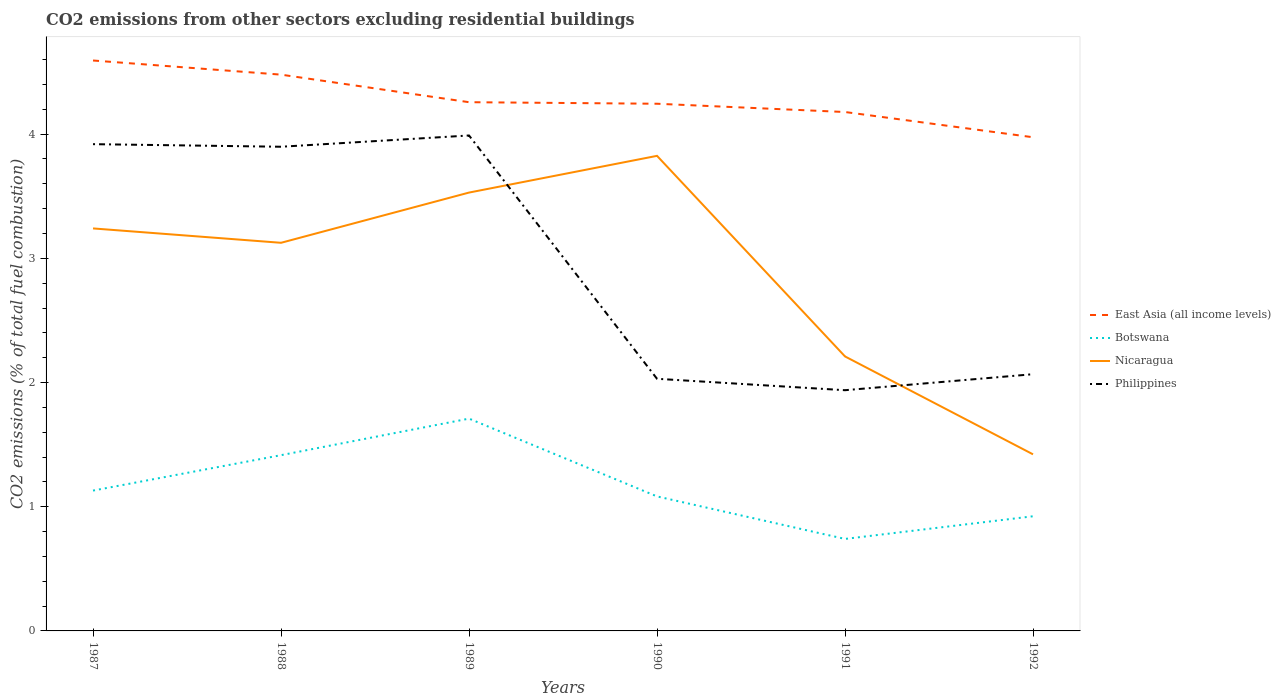How many different coloured lines are there?
Provide a short and direct response. 4. Does the line corresponding to Nicaragua intersect with the line corresponding to East Asia (all income levels)?
Offer a terse response. No. Across all years, what is the maximum total CO2 emitted in Nicaragua?
Make the answer very short. 1.42. What is the total total CO2 emitted in Philippines in the graph?
Keep it short and to the point. 1.89. What is the difference between the highest and the second highest total CO2 emitted in Philippines?
Offer a very short reply. 2.05. What is the difference between the highest and the lowest total CO2 emitted in East Asia (all income levels)?
Offer a very short reply. 2. Is the total CO2 emitted in Botswana strictly greater than the total CO2 emitted in Philippines over the years?
Provide a succinct answer. Yes. What is the difference between two consecutive major ticks on the Y-axis?
Provide a succinct answer. 1. Does the graph contain any zero values?
Offer a very short reply. No. Where does the legend appear in the graph?
Offer a terse response. Center right. What is the title of the graph?
Give a very brief answer. CO2 emissions from other sectors excluding residential buildings. What is the label or title of the Y-axis?
Offer a very short reply. CO2 emissions (% of total fuel combustion). What is the CO2 emissions (% of total fuel combustion) in East Asia (all income levels) in 1987?
Your answer should be very brief. 4.59. What is the CO2 emissions (% of total fuel combustion) in Botswana in 1987?
Offer a very short reply. 1.13. What is the CO2 emissions (% of total fuel combustion) in Nicaragua in 1987?
Give a very brief answer. 3.24. What is the CO2 emissions (% of total fuel combustion) of Philippines in 1987?
Keep it short and to the point. 3.92. What is the CO2 emissions (% of total fuel combustion) in East Asia (all income levels) in 1988?
Provide a short and direct response. 4.48. What is the CO2 emissions (% of total fuel combustion) of Botswana in 1988?
Offer a very short reply. 1.42. What is the CO2 emissions (% of total fuel combustion) in Nicaragua in 1988?
Your answer should be very brief. 3.12. What is the CO2 emissions (% of total fuel combustion) of Philippines in 1988?
Your answer should be compact. 3.9. What is the CO2 emissions (% of total fuel combustion) in East Asia (all income levels) in 1989?
Provide a succinct answer. 4.26. What is the CO2 emissions (% of total fuel combustion) of Botswana in 1989?
Make the answer very short. 1.71. What is the CO2 emissions (% of total fuel combustion) in Nicaragua in 1989?
Offer a terse response. 3.53. What is the CO2 emissions (% of total fuel combustion) of Philippines in 1989?
Ensure brevity in your answer.  3.99. What is the CO2 emissions (% of total fuel combustion) of East Asia (all income levels) in 1990?
Offer a very short reply. 4.24. What is the CO2 emissions (% of total fuel combustion) of Botswana in 1990?
Your answer should be very brief. 1.08. What is the CO2 emissions (% of total fuel combustion) in Nicaragua in 1990?
Keep it short and to the point. 3.83. What is the CO2 emissions (% of total fuel combustion) of Philippines in 1990?
Your response must be concise. 2.03. What is the CO2 emissions (% of total fuel combustion) of East Asia (all income levels) in 1991?
Offer a very short reply. 4.18. What is the CO2 emissions (% of total fuel combustion) in Botswana in 1991?
Your response must be concise. 0.74. What is the CO2 emissions (% of total fuel combustion) of Nicaragua in 1991?
Offer a terse response. 2.21. What is the CO2 emissions (% of total fuel combustion) of Philippines in 1991?
Give a very brief answer. 1.94. What is the CO2 emissions (% of total fuel combustion) of East Asia (all income levels) in 1992?
Make the answer very short. 3.97. What is the CO2 emissions (% of total fuel combustion) in Botswana in 1992?
Your response must be concise. 0.92. What is the CO2 emissions (% of total fuel combustion) of Nicaragua in 1992?
Your answer should be compact. 1.42. What is the CO2 emissions (% of total fuel combustion) in Philippines in 1992?
Provide a succinct answer. 2.07. Across all years, what is the maximum CO2 emissions (% of total fuel combustion) of East Asia (all income levels)?
Your response must be concise. 4.59. Across all years, what is the maximum CO2 emissions (% of total fuel combustion) of Botswana?
Keep it short and to the point. 1.71. Across all years, what is the maximum CO2 emissions (% of total fuel combustion) in Nicaragua?
Provide a succinct answer. 3.83. Across all years, what is the maximum CO2 emissions (% of total fuel combustion) of Philippines?
Give a very brief answer. 3.99. Across all years, what is the minimum CO2 emissions (% of total fuel combustion) in East Asia (all income levels)?
Ensure brevity in your answer.  3.97. Across all years, what is the minimum CO2 emissions (% of total fuel combustion) in Botswana?
Offer a terse response. 0.74. Across all years, what is the minimum CO2 emissions (% of total fuel combustion) in Nicaragua?
Provide a short and direct response. 1.42. Across all years, what is the minimum CO2 emissions (% of total fuel combustion) of Philippines?
Provide a short and direct response. 1.94. What is the total CO2 emissions (% of total fuel combustion) in East Asia (all income levels) in the graph?
Offer a terse response. 25.73. What is the total CO2 emissions (% of total fuel combustion) of Botswana in the graph?
Give a very brief answer. 7. What is the total CO2 emissions (% of total fuel combustion) in Nicaragua in the graph?
Your response must be concise. 17.35. What is the total CO2 emissions (% of total fuel combustion) of Philippines in the graph?
Provide a succinct answer. 17.84. What is the difference between the CO2 emissions (% of total fuel combustion) of East Asia (all income levels) in 1987 and that in 1988?
Offer a terse response. 0.11. What is the difference between the CO2 emissions (% of total fuel combustion) of Botswana in 1987 and that in 1988?
Your answer should be compact. -0.29. What is the difference between the CO2 emissions (% of total fuel combustion) in Nicaragua in 1987 and that in 1988?
Keep it short and to the point. 0.12. What is the difference between the CO2 emissions (% of total fuel combustion) in Philippines in 1987 and that in 1988?
Give a very brief answer. 0.02. What is the difference between the CO2 emissions (% of total fuel combustion) in East Asia (all income levels) in 1987 and that in 1989?
Provide a succinct answer. 0.34. What is the difference between the CO2 emissions (% of total fuel combustion) of Botswana in 1987 and that in 1989?
Keep it short and to the point. -0.58. What is the difference between the CO2 emissions (% of total fuel combustion) in Nicaragua in 1987 and that in 1989?
Provide a short and direct response. -0.29. What is the difference between the CO2 emissions (% of total fuel combustion) in Philippines in 1987 and that in 1989?
Offer a very short reply. -0.07. What is the difference between the CO2 emissions (% of total fuel combustion) of East Asia (all income levels) in 1987 and that in 1990?
Make the answer very short. 0.35. What is the difference between the CO2 emissions (% of total fuel combustion) of Botswana in 1987 and that in 1990?
Give a very brief answer. 0.05. What is the difference between the CO2 emissions (% of total fuel combustion) of Nicaragua in 1987 and that in 1990?
Provide a succinct answer. -0.58. What is the difference between the CO2 emissions (% of total fuel combustion) of Philippines in 1987 and that in 1990?
Provide a succinct answer. 1.89. What is the difference between the CO2 emissions (% of total fuel combustion) of East Asia (all income levels) in 1987 and that in 1991?
Ensure brevity in your answer.  0.41. What is the difference between the CO2 emissions (% of total fuel combustion) in Botswana in 1987 and that in 1991?
Offer a very short reply. 0.39. What is the difference between the CO2 emissions (% of total fuel combustion) in Nicaragua in 1987 and that in 1991?
Offer a terse response. 1.03. What is the difference between the CO2 emissions (% of total fuel combustion) of Philippines in 1987 and that in 1991?
Keep it short and to the point. 1.98. What is the difference between the CO2 emissions (% of total fuel combustion) in East Asia (all income levels) in 1987 and that in 1992?
Ensure brevity in your answer.  0.62. What is the difference between the CO2 emissions (% of total fuel combustion) in Botswana in 1987 and that in 1992?
Your answer should be very brief. 0.21. What is the difference between the CO2 emissions (% of total fuel combustion) of Nicaragua in 1987 and that in 1992?
Offer a very short reply. 1.82. What is the difference between the CO2 emissions (% of total fuel combustion) in Philippines in 1987 and that in 1992?
Your answer should be very brief. 1.85. What is the difference between the CO2 emissions (% of total fuel combustion) in East Asia (all income levels) in 1988 and that in 1989?
Your answer should be very brief. 0.22. What is the difference between the CO2 emissions (% of total fuel combustion) of Botswana in 1988 and that in 1989?
Ensure brevity in your answer.  -0.29. What is the difference between the CO2 emissions (% of total fuel combustion) of Nicaragua in 1988 and that in 1989?
Make the answer very short. -0.4. What is the difference between the CO2 emissions (% of total fuel combustion) of Philippines in 1988 and that in 1989?
Provide a short and direct response. -0.09. What is the difference between the CO2 emissions (% of total fuel combustion) of East Asia (all income levels) in 1988 and that in 1990?
Ensure brevity in your answer.  0.23. What is the difference between the CO2 emissions (% of total fuel combustion) in Botswana in 1988 and that in 1990?
Give a very brief answer. 0.33. What is the difference between the CO2 emissions (% of total fuel combustion) in Nicaragua in 1988 and that in 1990?
Your answer should be compact. -0.7. What is the difference between the CO2 emissions (% of total fuel combustion) of Philippines in 1988 and that in 1990?
Your response must be concise. 1.87. What is the difference between the CO2 emissions (% of total fuel combustion) in East Asia (all income levels) in 1988 and that in 1991?
Offer a terse response. 0.3. What is the difference between the CO2 emissions (% of total fuel combustion) in Botswana in 1988 and that in 1991?
Keep it short and to the point. 0.67. What is the difference between the CO2 emissions (% of total fuel combustion) in Nicaragua in 1988 and that in 1991?
Offer a terse response. 0.92. What is the difference between the CO2 emissions (% of total fuel combustion) of Philippines in 1988 and that in 1991?
Your answer should be very brief. 1.96. What is the difference between the CO2 emissions (% of total fuel combustion) in East Asia (all income levels) in 1988 and that in 1992?
Provide a short and direct response. 0.5. What is the difference between the CO2 emissions (% of total fuel combustion) in Botswana in 1988 and that in 1992?
Offer a terse response. 0.49. What is the difference between the CO2 emissions (% of total fuel combustion) of Nicaragua in 1988 and that in 1992?
Make the answer very short. 1.7. What is the difference between the CO2 emissions (% of total fuel combustion) in Philippines in 1988 and that in 1992?
Your response must be concise. 1.83. What is the difference between the CO2 emissions (% of total fuel combustion) of East Asia (all income levels) in 1989 and that in 1990?
Provide a succinct answer. 0.01. What is the difference between the CO2 emissions (% of total fuel combustion) in Botswana in 1989 and that in 1990?
Offer a terse response. 0.63. What is the difference between the CO2 emissions (% of total fuel combustion) in Nicaragua in 1989 and that in 1990?
Your response must be concise. -0.3. What is the difference between the CO2 emissions (% of total fuel combustion) in Philippines in 1989 and that in 1990?
Ensure brevity in your answer.  1.96. What is the difference between the CO2 emissions (% of total fuel combustion) in East Asia (all income levels) in 1989 and that in 1991?
Offer a very short reply. 0.08. What is the difference between the CO2 emissions (% of total fuel combustion) in Botswana in 1989 and that in 1991?
Keep it short and to the point. 0.97. What is the difference between the CO2 emissions (% of total fuel combustion) in Nicaragua in 1989 and that in 1991?
Offer a terse response. 1.32. What is the difference between the CO2 emissions (% of total fuel combustion) of Philippines in 1989 and that in 1991?
Your response must be concise. 2.05. What is the difference between the CO2 emissions (% of total fuel combustion) in East Asia (all income levels) in 1989 and that in 1992?
Provide a succinct answer. 0.28. What is the difference between the CO2 emissions (% of total fuel combustion) of Botswana in 1989 and that in 1992?
Provide a succinct answer. 0.79. What is the difference between the CO2 emissions (% of total fuel combustion) in Nicaragua in 1989 and that in 1992?
Keep it short and to the point. 2.11. What is the difference between the CO2 emissions (% of total fuel combustion) of Philippines in 1989 and that in 1992?
Keep it short and to the point. 1.92. What is the difference between the CO2 emissions (% of total fuel combustion) in East Asia (all income levels) in 1990 and that in 1991?
Your answer should be very brief. 0.07. What is the difference between the CO2 emissions (% of total fuel combustion) in Botswana in 1990 and that in 1991?
Provide a short and direct response. 0.34. What is the difference between the CO2 emissions (% of total fuel combustion) of Nicaragua in 1990 and that in 1991?
Your answer should be very brief. 1.62. What is the difference between the CO2 emissions (% of total fuel combustion) in Philippines in 1990 and that in 1991?
Ensure brevity in your answer.  0.09. What is the difference between the CO2 emissions (% of total fuel combustion) in East Asia (all income levels) in 1990 and that in 1992?
Give a very brief answer. 0.27. What is the difference between the CO2 emissions (% of total fuel combustion) in Botswana in 1990 and that in 1992?
Your answer should be very brief. 0.16. What is the difference between the CO2 emissions (% of total fuel combustion) of Nicaragua in 1990 and that in 1992?
Offer a very short reply. 2.4. What is the difference between the CO2 emissions (% of total fuel combustion) in Philippines in 1990 and that in 1992?
Your response must be concise. -0.04. What is the difference between the CO2 emissions (% of total fuel combustion) in East Asia (all income levels) in 1991 and that in 1992?
Provide a short and direct response. 0.2. What is the difference between the CO2 emissions (% of total fuel combustion) in Botswana in 1991 and that in 1992?
Provide a succinct answer. -0.18. What is the difference between the CO2 emissions (% of total fuel combustion) in Nicaragua in 1991 and that in 1992?
Your answer should be compact. 0.79. What is the difference between the CO2 emissions (% of total fuel combustion) of Philippines in 1991 and that in 1992?
Your response must be concise. -0.13. What is the difference between the CO2 emissions (% of total fuel combustion) in East Asia (all income levels) in 1987 and the CO2 emissions (% of total fuel combustion) in Botswana in 1988?
Your answer should be compact. 3.18. What is the difference between the CO2 emissions (% of total fuel combustion) of East Asia (all income levels) in 1987 and the CO2 emissions (% of total fuel combustion) of Nicaragua in 1988?
Ensure brevity in your answer.  1.47. What is the difference between the CO2 emissions (% of total fuel combustion) of East Asia (all income levels) in 1987 and the CO2 emissions (% of total fuel combustion) of Philippines in 1988?
Provide a succinct answer. 0.69. What is the difference between the CO2 emissions (% of total fuel combustion) in Botswana in 1987 and the CO2 emissions (% of total fuel combustion) in Nicaragua in 1988?
Ensure brevity in your answer.  -2. What is the difference between the CO2 emissions (% of total fuel combustion) of Botswana in 1987 and the CO2 emissions (% of total fuel combustion) of Philippines in 1988?
Your answer should be compact. -2.77. What is the difference between the CO2 emissions (% of total fuel combustion) of Nicaragua in 1987 and the CO2 emissions (% of total fuel combustion) of Philippines in 1988?
Your answer should be very brief. -0.66. What is the difference between the CO2 emissions (% of total fuel combustion) in East Asia (all income levels) in 1987 and the CO2 emissions (% of total fuel combustion) in Botswana in 1989?
Give a very brief answer. 2.88. What is the difference between the CO2 emissions (% of total fuel combustion) of East Asia (all income levels) in 1987 and the CO2 emissions (% of total fuel combustion) of Nicaragua in 1989?
Offer a terse response. 1.06. What is the difference between the CO2 emissions (% of total fuel combustion) of East Asia (all income levels) in 1987 and the CO2 emissions (% of total fuel combustion) of Philippines in 1989?
Your response must be concise. 0.6. What is the difference between the CO2 emissions (% of total fuel combustion) of Botswana in 1987 and the CO2 emissions (% of total fuel combustion) of Nicaragua in 1989?
Ensure brevity in your answer.  -2.4. What is the difference between the CO2 emissions (% of total fuel combustion) of Botswana in 1987 and the CO2 emissions (% of total fuel combustion) of Philippines in 1989?
Your answer should be compact. -2.86. What is the difference between the CO2 emissions (% of total fuel combustion) in Nicaragua in 1987 and the CO2 emissions (% of total fuel combustion) in Philippines in 1989?
Provide a succinct answer. -0.75. What is the difference between the CO2 emissions (% of total fuel combustion) in East Asia (all income levels) in 1987 and the CO2 emissions (% of total fuel combustion) in Botswana in 1990?
Provide a short and direct response. 3.51. What is the difference between the CO2 emissions (% of total fuel combustion) of East Asia (all income levels) in 1987 and the CO2 emissions (% of total fuel combustion) of Nicaragua in 1990?
Offer a terse response. 0.77. What is the difference between the CO2 emissions (% of total fuel combustion) of East Asia (all income levels) in 1987 and the CO2 emissions (% of total fuel combustion) of Philippines in 1990?
Provide a short and direct response. 2.56. What is the difference between the CO2 emissions (% of total fuel combustion) in Botswana in 1987 and the CO2 emissions (% of total fuel combustion) in Nicaragua in 1990?
Your response must be concise. -2.7. What is the difference between the CO2 emissions (% of total fuel combustion) of Botswana in 1987 and the CO2 emissions (% of total fuel combustion) of Philippines in 1990?
Your answer should be compact. -0.9. What is the difference between the CO2 emissions (% of total fuel combustion) of Nicaragua in 1987 and the CO2 emissions (% of total fuel combustion) of Philippines in 1990?
Your answer should be very brief. 1.21. What is the difference between the CO2 emissions (% of total fuel combustion) of East Asia (all income levels) in 1987 and the CO2 emissions (% of total fuel combustion) of Botswana in 1991?
Offer a very short reply. 3.85. What is the difference between the CO2 emissions (% of total fuel combustion) of East Asia (all income levels) in 1987 and the CO2 emissions (% of total fuel combustion) of Nicaragua in 1991?
Provide a short and direct response. 2.38. What is the difference between the CO2 emissions (% of total fuel combustion) in East Asia (all income levels) in 1987 and the CO2 emissions (% of total fuel combustion) in Philippines in 1991?
Provide a short and direct response. 2.65. What is the difference between the CO2 emissions (% of total fuel combustion) in Botswana in 1987 and the CO2 emissions (% of total fuel combustion) in Nicaragua in 1991?
Provide a succinct answer. -1.08. What is the difference between the CO2 emissions (% of total fuel combustion) of Botswana in 1987 and the CO2 emissions (% of total fuel combustion) of Philippines in 1991?
Give a very brief answer. -0.81. What is the difference between the CO2 emissions (% of total fuel combustion) in Nicaragua in 1987 and the CO2 emissions (% of total fuel combustion) in Philippines in 1991?
Your answer should be very brief. 1.3. What is the difference between the CO2 emissions (% of total fuel combustion) of East Asia (all income levels) in 1987 and the CO2 emissions (% of total fuel combustion) of Botswana in 1992?
Provide a short and direct response. 3.67. What is the difference between the CO2 emissions (% of total fuel combustion) of East Asia (all income levels) in 1987 and the CO2 emissions (% of total fuel combustion) of Nicaragua in 1992?
Provide a succinct answer. 3.17. What is the difference between the CO2 emissions (% of total fuel combustion) in East Asia (all income levels) in 1987 and the CO2 emissions (% of total fuel combustion) in Philippines in 1992?
Offer a very short reply. 2.53. What is the difference between the CO2 emissions (% of total fuel combustion) of Botswana in 1987 and the CO2 emissions (% of total fuel combustion) of Nicaragua in 1992?
Ensure brevity in your answer.  -0.29. What is the difference between the CO2 emissions (% of total fuel combustion) in Botswana in 1987 and the CO2 emissions (% of total fuel combustion) in Philippines in 1992?
Provide a short and direct response. -0.94. What is the difference between the CO2 emissions (% of total fuel combustion) in Nicaragua in 1987 and the CO2 emissions (% of total fuel combustion) in Philippines in 1992?
Ensure brevity in your answer.  1.17. What is the difference between the CO2 emissions (% of total fuel combustion) in East Asia (all income levels) in 1988 and the CO2 emissions (% of total fuel combustion) in Botswana in 1989?
Keep it short and to the point. 2.77. What is the difference between the CO2 emissions (% of total fuel combustion) in East Asia (all income levels) in 1988 and the CO2 emissions (% of total fuel combustion) in Nicaragua in 1989?
Make the answer very short. 0.95. What is the difference between the CO2 emissions (% of total fuel combustion) of East Asia (all income levels) in 1988 and the CO2 emissions (% of total fuel combustion) of Philippines in 1989?
Keep it short and to the point. 0.49. What is the difference between the CO2 emissions (% of total fuel combustion) of Botswana in 1988 and the CO2 emissions (% of total fuel combustion) of Nicaragua in 1989?
Give a very brief answer. -2.11. What is the difference between the CO2 emissions (% of total fuel combustion) of Botswana in 1988 and the CO2 emissions (% of total fuel combustion) of Philippines in 1989?
Provide a succinct answer. -2.57. What is the difference between the CO2 emissions (% of total fuel combustion) in Nicaragua in 1988 and the CO2 emissions (% of total fuel combustion) in Philippines in 1989?
Make the answer very short. -0.86. What is the difference between the CO2 emissions (% of total fuel combustion) in East Asia (all income levels) in 1988 and the CO2 emissions (% of total fuel combustion) in Botswana in 1990?
Make the answer very short. 3.4. What is the difference between the CO2 emissions (% of total fuel combustion) of East Asia (all income levels) in 1988 and the CO2 emissions (% of total fuel combustion) of Nicaragua in 1990?
Keep it short and to the point. 0.65. What is the difference between the CO2 emissions (% of total fuel combustion) of East Asia (all income levels) in 1988 and the CO2 emissions (% of total fuel combustion) of Philippines in 1990?
Your response must be concise. 2.45. What is the difference between the CO2 emissions (% of total fuel combustion) of Botswana in 1988 and the CO2 emissions (% of total fuel combustion) of Nicaragua in 1990?
Provide a short and direct response. -2.41. What is the difference between the CO2 emissions (% of total fuel combustion) of Botswana in 1988 and the CO2 emissions (% of total fuel combustion) of Philippines in 1990?
Make the answer very short. -0.61. What is the difference between the CO2 emissions (% of total fuel combustion) of Nicaragua in 1988 and the CO2 emissions (% of total fuel combustion) of Philippines in 1990?
Offer a terse response. 1.09. What is the difference between the CO2 emissions (% of total fuel combustion) of East Asia (all income levels) in 1988 and the CO2 emissions (% of total fuel combustion) of Botswana in 1991?
Provide a short and direct response. 3.74. What is the difference between the CO2 emissions (% of total fuel combustion) in East Asia (all income levels) in 1988 and the CO2 emissions (% of total fuel combustion) in Nicaragua in 1991?
Give a very brief answer. 2.27. What is the difference between the CO2 emissions (% of total fuel combustion) of East Asia (all income levels) in 1988 and the CO2 emissions (% of total fuel combustion) of Philippines in 1991?
Provide a short and direct response. 2.54. What is the difference between the CO2 emissions (% of total fuel combustion) of Botswana in 1988 and the CO2 emissions (% of total fuel combustion) of Nicaragua in 1991?
Offer a very short reply. -0.79. What is the difference between the CO2 emissions (% of total fuel combustion) of Botswana in 1988 and the CO2 emissions (% of total fuel combustion) of Philippines in 1991?
Your answer should be very brief. -0.52. What is the difference between the CO2 emissions (% of total fuel combustion) in Nicaragua in 1988 and the CO2 emissions (% of total fuel combustion) in Philippines in 1991?
Offer a very short reply. 1.19. What is the difference between the CO2 emissions (% of total fuel combustion) in East Asia (all income levels) in 1988 and the CO2 emissions (% of total fuel combustion) in Botswana in 1992?
Offer a terse response. 3.56. What is the difference between the CO2 emissions (% of total fuel combustion) in East Asia (all income levels) in 1988 and the CO2 emissions (% of total fuel combustion) in Nicaragua in 1992?
Keep it short and to the point. 3.06. What is the difference between the CO2 emissions (% of total fuel combustion) in East Asia (all income levels) in 1988 and the CO2 emissions (% of total fuel combustion) in Philippines in 1992?
Your response must be concise. 2.41. What is the difference between the CO2 emissions (% of total fuel combustion) of Botswana in 1988 and the CO2 emissions (% of total fuel combustion) of Nicaragua in 1992?
Make the answer very short. -0.01. What is the difference between the CO2 emissions (% of total fuel combustion) of Botswana in 1988 and the CO2 emissions (% of total fuel combustion) of Philippines in 1992?
Offer a terse response. -0.65. What is the difference between the CO2 emissions (% of total fuel combustion) of Nicaragua in 1988 and the CO2 emissions (% of total fuel combustion) of Philippines in 1992?
Your answer should be compact. 1.06. What is the difference between the CO2 emissions (% of total fuel combustion) of East Asia (all income levels) in 1989 and the CO2 emissions (% of total fuel combustion) of Botswana in 1990?
Offer a terse response. 3.17. What is the difference between the CO2 emissions (% of total fuel combustion) of East Asia (all income levels) in 1989 and the CO2 emissions (% of total fuel combustion) of Nicaragua in 1990?
Provide a short and direct response. 0.43. What is the difference between the CO2 emissions (% of total fuel combustion) in East Asia (all income levels) in 1989 and the CO2 emissions (% of total fuel combustion) in Philippines in 1990?
Ensure brevity in your answer.  2.23. What is the difference between the CO2 emissions (% of total fuel combustion) of Botswana in 1989 and the CO2 emissions (% of total fuel combustion) of Nicaragua in 1990?
Your answer should be very brief. -2.12. What is the difference between the CO2 emissions (% of total fuel combustion) in Botswana in 1989 and the CO2 emissions (% of total fuel combustion) in Philippines in 1990?
Provide a short and direct response. -0.32. What is the difference between the CO2 emissions (% of total fuel combustion) in Nicaragua in 1989 and the CO2 emissions (% of total fuel combustion) in Philippines in 1990?
Make the answer very short. 1.5. What is the difference between the CO2 emissions (% of total fuel combustion) in East Asia (all income levels) in 1989 and the CO2 emissions (% of total fuel combustion) in Botswana in 1991?
Keep it short and to the point. 3.52. What is the difference between the CO2 emissions (% of total fuel combustion) of East Asia (all income levels) in 1989 and the CO2 emissions (% of total fuel combustion) of Nicaragua in 1991?
Provide a succinct answer. 2.05. What is the difference between the CO2 emissions (% of total fuel combustion) in East Asia (all income levels) in 1989 and the CO2 emissions (% of total fuel combustion) in Philippines in 1991?
Keep it short and to the point. 2.32. What is the difference between the CO2 emissions (% of total fuel combustion) of Botswana in 1989 and the CO2 emissions (% of total fuel combustion) of Nicaragua in 1991?
Your response must be concise. -0.5. What is the difference between the CO2 emissions (% of total fuel combustion) in Botswana in 1989 and the CO2 emissions (% of total fuel combustion) in Philippines in 1991?
Your answer should be compact. -0.23. What is the difference between the CO2 emissions (% of total fuel combustion) in Nicaragua in 1989 and the CO2 emissions (% of total fuel combustion) in Philippines in 1991?
Offer a very short reply. 1.59. What is the difference between the CO2 emissions (% of total fuel combustion) of East Asia (all income levels) in 1989 and the CO2 emissions (% of total fuel combustion) of Botswana in 1992?
Provide a short and direct response. 3.33. What is the difference between the CO2 emissions (% of total fuel combustion) of East Asia (all income levels) in 1989 and the CO2 emissions (% of total fuel combustion) of Nicaragua in 1992?
Make the answer very short. 2.84. What is the difference between the CO2 emissions (% of total fuel combustion) in East Asia (all income levels) in 1989 and the CO2 emissions (% of total fuel combustion) in Philippines in 1992?
Your response must be concise. 2.19. What is the difference between the CO2 emissions (% of total fuel combustion) in Botswana in 1989 and the CO2 emissions (% of total fuel combustion) in Nicaragua in 1992?
Ensure brevity in your answer.  0.29. What is the difference between the CO2 emissions (% of total fuel combustion) in Botswana in 1989 and the CO2 emissions (% of total fuel combustion) in Philippines in 1992?
Keep it short and to the point. -0.36. What is the difference between the CO2 emissions (% of total fuel combustion) in Nicaragua in 1989 and the CO2 emissions (% of total fuel combustion) in Philippines in 1992?
Offer a very short reply. 1.46. What is the difference between the CO2 emissions (% of total fuel combustion) in East Asia (all income levels) in 1990 and the CO2 emissions (% of total fuel combustion) in Botswana in 1991?
Offer a terse response. 3.5. What is the difference between the CO2 emissions (% of total fuel combustion) of East Asia (all income levels) in 1990 and the CO2 emissions (% of total fuel combustion) of Nicaragua in 1991?
Provide a succinct answer. 2.03. What is the difference between the CO2 emissions (% of total fuel combustion) of East Asia (all income levels) in 1990 and the CO2 emissions (% of total fuel combustion) of Philippines in 1991?
Your answer should be compact. 2.31. What is the difference between the CO2 emissions (% of total fuel combustion) in Botswana in 1990 and the CO2 emissions (% of total fuel combustion) in Nicaragua in 1991?
Keep it short and to the point. -1.13. What is the difference between the CO2 emissions (% of total fuel combustion) in Botswana in 1990 and the CO2 emissions (% of total fuel combustion) in Philippines in 1991?
Your response must be concise. -0.86. What is the difference between the CO2 emissions (% of total fuel combustion) in Nicaragua in 1990 and the CO2 emissions (% of total fuel combustion) in Philippines in 1991?
Make the answer very short. 1.89. What is the difference between the CO2 emissions (% of total fuel combustion) in East Asia (all income levels) in 1990 and the CO2 emissions (% of total fuel combustion) in Botswana in 1992?
Make the answer very short. 3.32. What is the difference between the CO2 emissions (% of total fuel combustion) of East Asia (all income levels) in 1990 and the CO2 emissions (% of total fuel combustion) of Nicaragua in 1992?
Your response must be concise. 2.82. What is the difference between the CO2 emissions (% of total fuel combustion) of East Asia (all income levels) in 1990 and the CO2 emissions (% of total fuel combustion) of Philippines in 1992?
Ensure brevity in your answer.  2.18. What is the difference between the CO2 emissions (% of total fuel combustion) in Botswana in 1990 and the CO2 emissions (% of total fuel combustion) in Nicaragua in 1992?
Ensure brevity in your answer.  -0.34. What is the difference between the CO2 emissions (% of total fuel combustion) of Botswana in 1990 and the CO2 emissions (% of total fuel combustion) of Philippines in 1992?
Your response must be concise. -0.98. What is the difference between the CO2 emissions (% of total fuel combustion) in Nicaragua in 1990 and the CO2 emissions (% of total fuel combustion) in Philippines in 1992?
Your response must be concise. 1.76. What is the difference between the CO2 emissions (% of total fuel combustion) of East Asia (all income levels) in 1991 and the CO2 emissions (% of total fuel combustion) of Botswana in 1992?
Give a very brief answer. 3.25. What is the difference between the CO2 emissions (% of total fuel combustion) of East Asia (all income levels) in 1991 and the CO2 emissions (% of total fuel combustion) of Nicaragua in 1992?
Your response must be concise. 2.76. What is the difference between the CO2 emissions (% of total fuel combustion) in East Asia (all income levels) in 1991 and the CO2 emissions (% of total fuel combustion) in Philippines in 1992?
Keep it short and to the point. 2.11. What is the difference between the CO2 emissions (% of total fuel combustion) in Botswana in 1991 and the CO2 emissions (% of total fuel combustion) in Nicaragua in 1992?
Your response must be concise. -0.68. What is the difference between the CO2 emissions (% of total fuel combustion) in Botswana in 1991 and the CO2 emissions (% of total fuel combustion) in Philippines in 1992?
Your response must be concise. -1.33. What is the difference between the CO2 emissions (% of total fuel combustion) of Nicaragua in 1991 and the CO2 emissions (% of total fuel combustion) of Philippines in 1992?
Provide a short and direct response. 0.14. What is the average CO2 emissions (% of total fuel combustion) of East Asia (all income levels) per year?
Your response must be concise. 4.29. What is the average CO2 emissions (% of total fuel combustion) in Botswana per year?
Give a very brief answer. 1.17. What is the average CO2 emissions (% of total fuel combustion) of Nicaragua per year?
Offer a very short reply. 2.89. What is the average CO2 emissions (% of total fuel combustion) of Philippines per year?
Ensure brevity in your answer.  2.97. In the year 1987, what is the difference between the CO2 emissions (% of total fuel combustion) of East Asia (all income levels) and CO2 emissions (% of total fuel combustion) of Botswana?
Offer a very short reply. 3.46. In the year 1987, what is the difference between the CO2 emissions (% of total fuel combustion) of East Asia (all income levels) and CO2 emissions (% of total fuel combustion) of Nicaragua?
Offer a very short reply. 1.35. In the year 1987, what is the difference between the CO2 emissions (% of total fuel combustion) of East Asia (all income levels) and CO2 emissions (% of total fuel combustion) of Philippines?
Keep it short and to the point. 0.67. In the year 1987, what is the difference between the CO2 emissions (% of total fuel combustion) of Botswana and CO2 emissions (% of total fuel combustion) of Nicaragua?
Offer a terse response. -2.11. In the year 1987, what is the difference between the CO2 emissions (% of total fuel combustion) of Botswana and CO2 emissions (% of total fuel combustion) of Philippines?
Provide a succinct answer. -2.79. In the year 1987, what is the difference between the CO2 emissions (% of total fuel combustion) in Nicaragua and CO2 emissions (% of total fuel combustion) in Philippines?
Your response must be concise. -0.68. In the year 1988, what is the difference between the CO2 emissions (% of total fuel combustion) in East Asia (all income levels) and CO2 emissions (% of total fuel combustion) in Botswana?
Give a very brief answer. 3.06. In the year 1988, what is the difference between the CO2 emissions (% of total fuel combustion) in East Asia (all income levels) and CO2 emissions (% of total fuel combustion) in Nicaragua?
Offer a very short reply. 1.35. In the year 1988, what is the difference between the CO2 emissions (% of total fuel combustion) of East Asia (all income levels) and CO2 emissions (% of total fuel combustion) of Philippines?
Offer a very short reply. 0.58. In the year 1988, what is the difference between the CO2 emissions (% of total fuel combustion) in Botswana and CO2 emissions (% of total fuel combustion) in Nicaragua?
Provide a succinct answer. -1.71. In the year 1988, what is the difference between the CO2 emissions (% of total fuel combustion) in Botswana and CO2 emissions (% of total fuel combustion) in Philippines?
Provide a succinct answer. -2.48. In the year 1988, what is the difference between the CO2 emissions (% of total fuel combustion) in Nicaragua and CO2 emissions (% of total fuel combustion) in Philippines?
Your answer should be compact. -0.77. In the year 1989, what is the difference between the CO2 emissions (% of total fuel combustion) of East Asia (all income levels) and CO2 emissions (% of total fuel combustion) of Botswana?
Your answer should be compact. 2.55. In the year 1989, what is the difference between the CO2 emissions (% of total fuel combustion) in East Asia (all income levels) and CO2 emissions (% of total fuel combustion) in Nicaragua?
Ensure brevity in your answer.  0.73. In the year 1989, what is the difference between the CO2 emissions (% of total fuel combustion) in East Asia (all income levels) and CO2 emissions (% of total fuel combustion) in Philippines?
Make the answer very short. 0.27. In the year 1989, what is the difference between the CO2 emissions (% of total fuel combustion) of Botswana and CO2 emissions (% of total fuel combustion) of Nicaragua?
Provide a succinct answer. -1.82. In the year 1989, what is the difference between the CO2 emissions (% of total fuel combustion) in Botswana and CO2 emissions (% of total fuel combustion) in Philippines?
Provide a short and direct response. -2.28. In the year 1989, what is the difference between the CO2 emissions (% of total fuel combustion) of Nicaragua and CO2 emissions (% of total fuel combustion) of Philippines?
Give a very brief answer. -0.46. In the year 1990, what is the difference between the CO2 emissions (% of total fuel combustion) in East Asia (all income levels) and CO2 emissions (% of total fuel combustion) in Botswana?
Your answer should be compact. 3.16. In the year 1990, what is the difference between the CO2 emissions (% of total fuel combustion) of East Asia (all income levels) and CO2 emissions (% of total fuel combustion) of Nicaragua?
Keep it short and to the point. 0.42. In the year 1990, what is the difference between the CO2 emissions (% of total fuel combustion) in East Asia (all income levels) and CO2 emissions (% of total fuel combustion) in Philippines?
Keep it short and to the point. 2.21. In the year 1990, what is the difference between the CO2 emissions (% of total fuel combustion) in Botswana and CO2 emissions (% of total fuel combustion) in Nicaragua?
Keep it short and to the point. -2.74. In the year 1990, what is the difference between the CO2 emissions (% of total fuel combustion) in Botswana and CO2 emissions (% of total fuel combustion) in Philippines?
Keep it short and to the point. -0.95. In the year 1990, what is the difference between the CO2 emissions (% of total fuel combustion) in Nicaragua and CO2 emissions (% of total fuel combustion) in Philippines?
Your answer should be very brief. 1.8. In the year 1991, what is the difference between the CO2 emissions (% of total fuel combustion) in East Asia (all income levels) and CO2 emissions (% of total fuel combustion) in Botswana?
Make the answer very short. 3.44. In the year 1991, what is the difference between the CO2 emissions (% of total fuel combustion) of East Asia (all income levels) and CO2 emissions (% of total fuel combustion) of Nicaragua?
Your answer should be very brief. 1.97. In the year 1991, what is the difference between the CO2 emissions (% of total fuel combustion) in East Asia (all income levels) and CO2 emissions (% of total fuel combustion) in Philippines?
Your answer should be compact. 2.24. In the year 1991, what is the difference between the CO2 emissions (% of total fuel combustion) in Botswana and CO2 emissions (% of total fuel combustion) in Nicaragua?
Your answer should be compact. -1.47. In the year 1991, what is the difference between the CO2 emissions (% of total fuel combustion) in Botswana and CO2 emissions (% of total fuel combustion) in Philippines?
Your answer should be compact. -1.2. In the year 1991, what is the difference between the CO2 emissions (% of total fuel combustion) of Nicaragua and CO2 emissions (% of total fuel combustion) of Philippines?
Offer a very short reply. 0.27. In the year 1992, what is the difference between the CO2 emissions (% of total fuel combustion) of East Asia (all income levels) and CO2 emissions (% of total fuel combustion) of Botswana?
Provide a succinct answer. 3.05. In the year 1992, what is the difference between the CO2 emissions (% of total fuel combustion) in East Asia (all income levels) and CO2 emissions (% of total fuel combustion) in Nicaragua?
Provide a short and direct response. 2.55. In the year 1992, what is the difference between the CO2 emissions (% of total fuel combustion) of East Asia (all income levels) and CO2 emissions (% of total fuel combustion) of Philippines?
Offer a very short reply. 1.91. In the year 1992, what is the difference between the CO2 emissions (% of total fuel combustion) in Botswana and CO2 emissions (% of total fuel combustion) in Nicaragua?
Keep it short and to the point. -0.5. In the year 1992, what is the difference between the CO2 emissions (% of total fuel combustion) in Botswana and CO2 emissions (% of total fuel combustion) in Philippines?
Provide a succinct answer. -1.14. In the year 1992, what is the difference between the CO2 emissions (% of total fuel combustion) of Nicaragua and CO2 emissions (% of total fuel combustion) of Philippines?
Keep it short and to the point. -0.65. What is the ratio of the CO2 emissions (% of total fuel combustion) of East Asia (all income levels) in 1987 to that in 1988?
Give a very brief answer. 1.03. What is the ratio of the CO2 emissions (% of total fuel combustion) of Botswana in 1987 to that in 1988?
Provide a succinct answer. 0.8. What is the ratio of the CO2 emissions (% of total fuel combustion) in Nicaragua in 1987 to that in 1988?
Offer a terse response. 1.04. What is the ratio of the CO2 emissions (% of total fuel combustion) in East Asia (all income levels) in 1987 to that in 1989?
Your response must be concise. 1.08. What is the ratio of the CO2 emissions (% of total fuel combustion) of Botswana in 1987 to that in 1989?
Offer a terse response. 0.66. What is the ratio of the CO2 emissions (% of total fuel combustion) in Nicaragua in 1987 to that in 1989?
Provide a succinct answer. 0.92. What is the ratio of the CO2 emissions (% of total fuel combustion) in Philippines in 1987 to that in 1989?
Your answer should be compact. 0.98. What is the ratio of the CO2 emissions (% of total fuel combustion) in East Asia (all income levels) in 1987 to that in 1990?
Your answer should be compact. 1.08. What is the ratio of the CO2 emissions (% of total fuel combustion) of Botswana in 1987 to that in 1990?
Offer a terse response. 1.04. What is the ratio of the CO2 emissions (% of total fuel combustion) in Nicaragua in 1987 to that in 1990?
Your answer should be compact. 0.85. What is the ratio of the CO2 emissions (% of total fuel combustion) in Philippines in 1987 to that in 1990?
Ensure brevity in your answer.  1.93. What is the ratio of the CO2 emissions (% of total fuel combustion) in East Asia (all income levels) in 1987 to that in 1991?
Ensure brevity in your answer.  1.1. What is the ratio of the CO2 emissions (% of total fuel combustion) of Botswana in 1987 to that in 1991?
Provide a short and direct response. 1.53. What is the ratio of the CO2 emissions (% of total fuel combustion) of Nicaragua in 1987 to that in 1991?
Offer a very short reply. 1.47. What is the ratio of the CO2 emissions (% of total fuel combustion) of Philippines in 1987 to that in 1991?
Offer a very short reply. 2.02. What is the ratio of the CO2 emissions (% of total fuel combustion) in East Asia (all income levels) in 1987 to that in 1992?
Provide a short and direct response. 1.16. What is the ratio of the CO2 emissions (% of total fuel combustion) in Botswana in 1987 to that in 1992?
Give a very brief answer. 1.22. What is the ratio of the CO2 emissions (% of total fuel combustion) of Nicaragua in 1987 to that in 1992?
Offer a terse response. 2.28. What is the ratio of the CO2 emissions (% of total fuel combustion) in Philippines in 1987 to that in 1992?
Provide a short and direct response. 1.9. What is the ratio of the CO2 emissions (% of total fuel combustion) of East Asia (all income levels) in 1988 to that in 1989?
Provide a short and direct response. 1.05. What is the ratio of the CO2 emissions (% of total fuel combustion) in Botswana in 1988 to that in 1989?
Your answer should be compact. 0.83. What is the ratio of the CO2 emissions (% of total fuel combustion) in Nicaragua in 1988 to that in 1989?
Give a very brief answer. 0.89. What is the ratio of the CO2 emissions (% of total fuel combustion) in Philippines in 1988 to that in 1989?
Keep it short and to the point. 0.98. What is the ratio of the CO2 emissions (% of total fuel combustion) in East Asia (all income levels) in 1988 to that in 1990?
Provide a short and direct response. 1.06. What is the ratio of the CO2 emissions (% of total fuel combustion) in Botswana in 1988 to that in 1990?
Your response must be concise. 1.31. What is the ratio of the CO2 emissions (% of total fuel combustion) of Nicaragua in 1988 to that in 1990?
Ensure brevity in your answer.  0.82. What is the ratio of the CO2 emissions (% of total fuel combustion) of Philippines in 1988 to that in 1990?
Keep it short and to the point. 1.92. What is the ratio of the CO2 emissions (% of total fuel combustion) in East Asia (all income levels) in 1988 to that in 1991?
Your response must be concise. 1.07. What is the ratio of the CO2 emissions (% of total fuel combustion) in Botswana in 1988 to that in 1991?
Keep it short and to the point. 1.91. What is the ratio of the CO2 emissions (% of total fuel combustion) in Nicaragua in 1988 to that in 1991?
Give a very brief answer. 1.41. What is the ratio of the CO2 emissions (% of total fuel combustion) in Philippines in 1988 to that in 1991?
Your answer should be compact. 2.01. What is the ratio of the CO2 emissions (% of total fuel combustion) in East Asia (all income levels) in 1988 to that in 1992?
Provide a succinct answer. 1.13. What is the ratio of the CO2 emissions (% of total fuel combustion) in Botswana in 1988 to that in 1992?
Make the answer very short. 1.53. What is the ratio of the CO2 emissions (% of total fuel combustion) in Nicaragua in 1988 to that in 1992?
Your answer should be very brief. 2.2. What is the ratio of the CO2 emissions (% of total fuel combustion) in Philippines in 1988 to that in 1992?
Your answer should be compact. 1.89. What is the ratio of the CO2 emissions (% of total fuel combustion) in East Asia (all income levels) in 1989 to that in 1990?
Offer a terse response. 1. What is the ratio of the CO2 emissions (% of total fuel combustion) of Botswana in 1989 to that in 1990?
Provide a succinct answer. 1.58. What is the ratio of the CO2 emissions (% of total fuel combustion) in Nicaragua in 1989 to that in 1990?
Offer a very short reply. 0.92. What is the ratio of the CO2 emissions (% of total fuel combustion) in Philippines in 1989 to that in 1990?
Your answer should be compact. 1.97. What is the ratio of the CO2 emissions (% of total fuel combustion) in East Asia (all income levels) in 1989 to that in 1991?
Your answer should be very brief. 1.02. What is the ratio of the CO2 emissions (% of total fuel combustion) of Botswana in 1989 to that in 1991?
Give a very brief answer. 2.31. What is the ratio of the CO2 emissions (% of total fuel combustion) of Nicaragua in 1989 to that in 1991?
Offer a terse response. 1.6. What is the ratio of the CO2 emissions (% of total fuel combustion) of Philippines in 1989 to that in 1991?
Offer a terse response. 2.06. What is the ratio of the CO2 emissions (% of total fuel combustion) of East Asia (all income levels) in 1989 to that in 1992?
Ensure brevity in your answer.  1.07. What is the ratio of the CO2 emissions (% of total fuel combustion) in Botswana in 1989 to that in 1992?
Your response must be concise. 1.85. What is the ratio of the CO2 emissions (% of total fuel combustion) in Nicaragua in 1989 to that in 1992?
Provide a succinct answer. 2.48. What is the ratio of the CO2 emissions (% of total fuel combustion) of Philippines in 1989 to that in 1992?
Your answer should be very brief. 1.93. What is the ratio of the CO2 emissions (% of total fuel combustion) in East Asia (all income levels) in 1990 to that in 1991?
Provide a short and direct response. 1.02. What is the ratio of the CO2 emissions (% of total fuel combustion) of Botswana in 1990 to that in 1991?
Offer a very short reply. 1.46. What is the ratio of the CO2 emissions (% of total fuel combustion) of Nicaragua in 1990 to that in 1991?
Give a very brief answer. 1.73. What is the ratio of the CO2 emissions (% of total fuel combustion) in Philippines in 1990 to that in 1991?
Provide a short and direct response. 1.05. What is the ratio of the CO2 emissions (% of total fuel combustion) of East Asia (all income levels) in 1990 to that in 1992?
Offer a very short reply. 1.07. What is the ratio of the CO2 emissions (% of total fuel combustion) in Botswana in 1990 to that in 1992?
Offer a terse response. 1.17. What is the ratio of the CO2 emissions (% of total fuel combustion) in Nicaragua in 1990 to that in 1992?
Give a very brief answer. 2.69. What is the ratio of the CO2 emissions (% of total fuel combustion) of Philippines in 1990 to that in 1992?
Offer a very short reply. 0.98. What is the ratio of the CO2 emissions (% of total fuel combustion) of East Asia (all income levels) in 1991 to that in 1992?
Give a very brief answer. 1.05. What is the ratio of the CO2 emissions (% of total fuel combustion) of Botswana in 1991 to that in 1992?
Your answer should be very brief. 0.8. What is the ratio of the CO2 emissions (% of total fuel combustion) of Nicaragua in 1991 to that in 1992?
Your answer should be very brief. 1.55. What is the ratio of the CO2 emissions (% of total fuel combustion) in Philippines in 1991 to that in 1992?
Your response must be concise. 0.94. What is the difference between the highest and the second highest CO2 emissions (% of total fuel combustion) of East Asia (all income levels)?
Offer a terse response. 0.11. What is the difference between the highest and the second highest CO2 emissions (% of total fuel combustion) in Botswana?
Ensure brevity in your answer.  0.29. What is the difference between the highest and the second highest CO2 emissions (% of total fuel combustion) in Nicaragua?
Make the answer very short. 0.3. What is the difference between the highest and the second highest CO2 emissions (% of total fuel combustion) of Philippines?
Offer a terse response. 0.07. What is the difference between the highest and the lowest CO2 emissions (% of total fuel combustion) in East Asia (all income levels)?
Your answer should be compact. 0.62. What is the difference between the highest and the lowest CO2 emissions (% of total fuel combustion) in Botswana?
Your answer should be very brief. 0.97. What is the difference between the highest and the lowest CO2 emissions (% of total fuel combustion) of Nicaragua?
Offer a very short reply. 2.4. What is the difference between the highest and the lowest CO2 emissions (% of total fuel combustion) of Philippines?
Give a very brief answer. 2.05. 